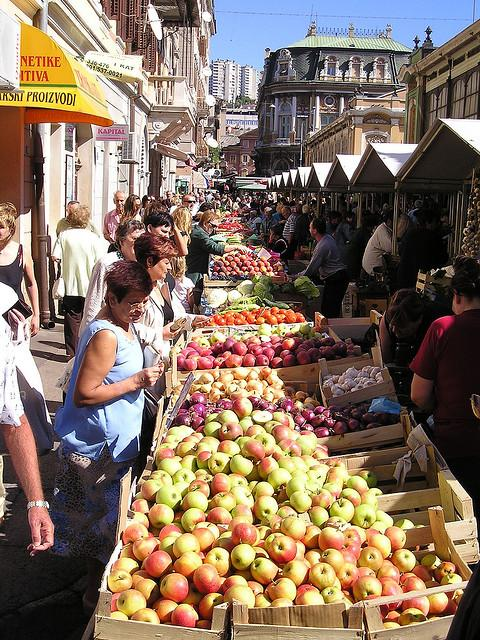Where does a shopper look to see how much a certain fruit costs?

Choices:
A) cardboard sign
B) tent flap
C) no where
D) vendors nametag cardboard sign 